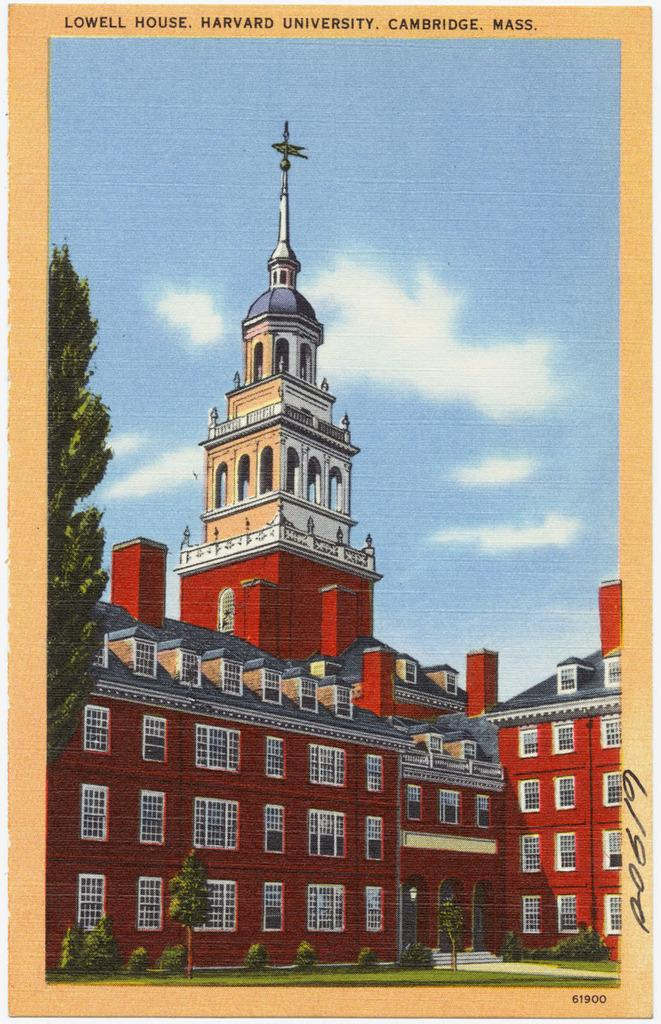What is featured in the image? There is a poster in the image. What is shown on the poster? The poster depicts a big building. Are there any other elements in the poster besides the building? Yes, there are plants and a tree in front of the building in the poster. Is there any smoke coming from the building in the poster? No, there is no smoke depicted in the poster. What type of rake is being used to maintain the plants in front of the building in the poster? There is no rake present in the image or the poster; it only shows a tree and plants. 